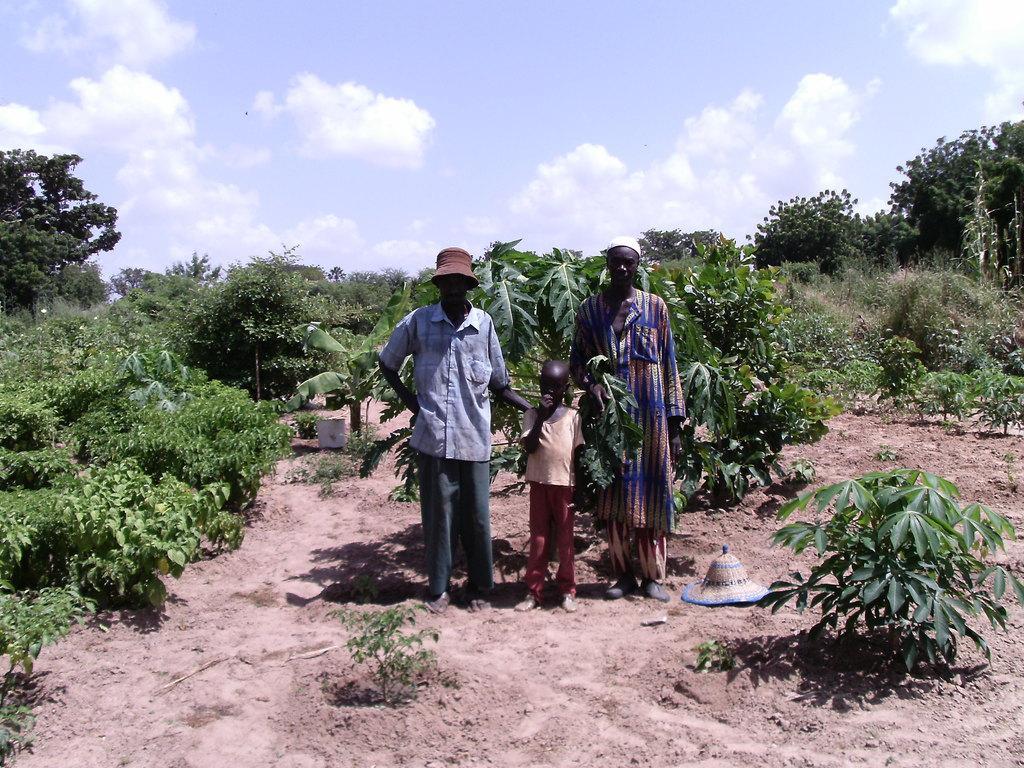How would you summarize this image in a sentence or two? In this image we can see three persons standing and we can also see plants, trees, sand, cap and in the background we can see the sky. 